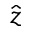<formula> <loc_0><loc_0><loc_500><loc_500>\hat { z }</formula> 